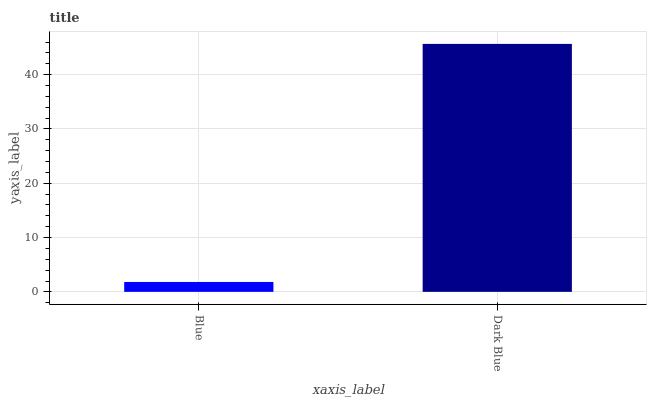Is Dark Blue the minimum?
Answer yes or no. No. Is Dark Blue greater than Blue?
Answer yes or no. Yes. Is Blue less than Dark Blue?
Answer yes or no. Yes. Is Blue greater than Dark Blue?
Answer yes or no. No. Is Dark Blue less than Blue?
Answer yes or no. No. Is Dark Blue the high median?
Answer yes or no. Yes. Is Blue the low median?
Answer yes or no. Yes. Is Blue the high median?
Answer yes or no. No. Is Dark Blue the low median?
Answer yes or no. No. 